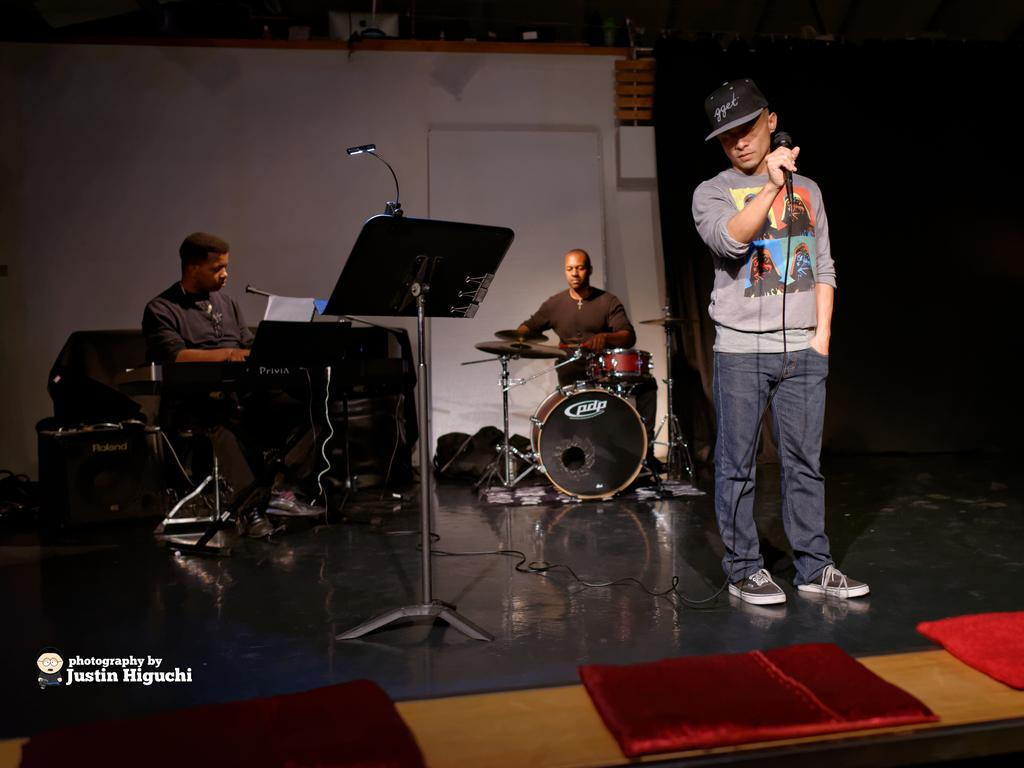How many men are present in the image? There are three men in the image. What are the positions of the men in the image? Two of the men are sitting, and one man is standing. What is the standing man holding? The standing man is holding a mic. What musical instrument can be seen in the image? There is a drum set in the image. What is the purpose of the stand in the image? The purpose of the stand is not clear from the provided facts, but it could be used to hold a microphone or other equipment. How many houses are visible in the image? There are no houses visible in the image. What type of spark can be seen coming from the mic in the image? There is no spark coming from the mic in the image. 